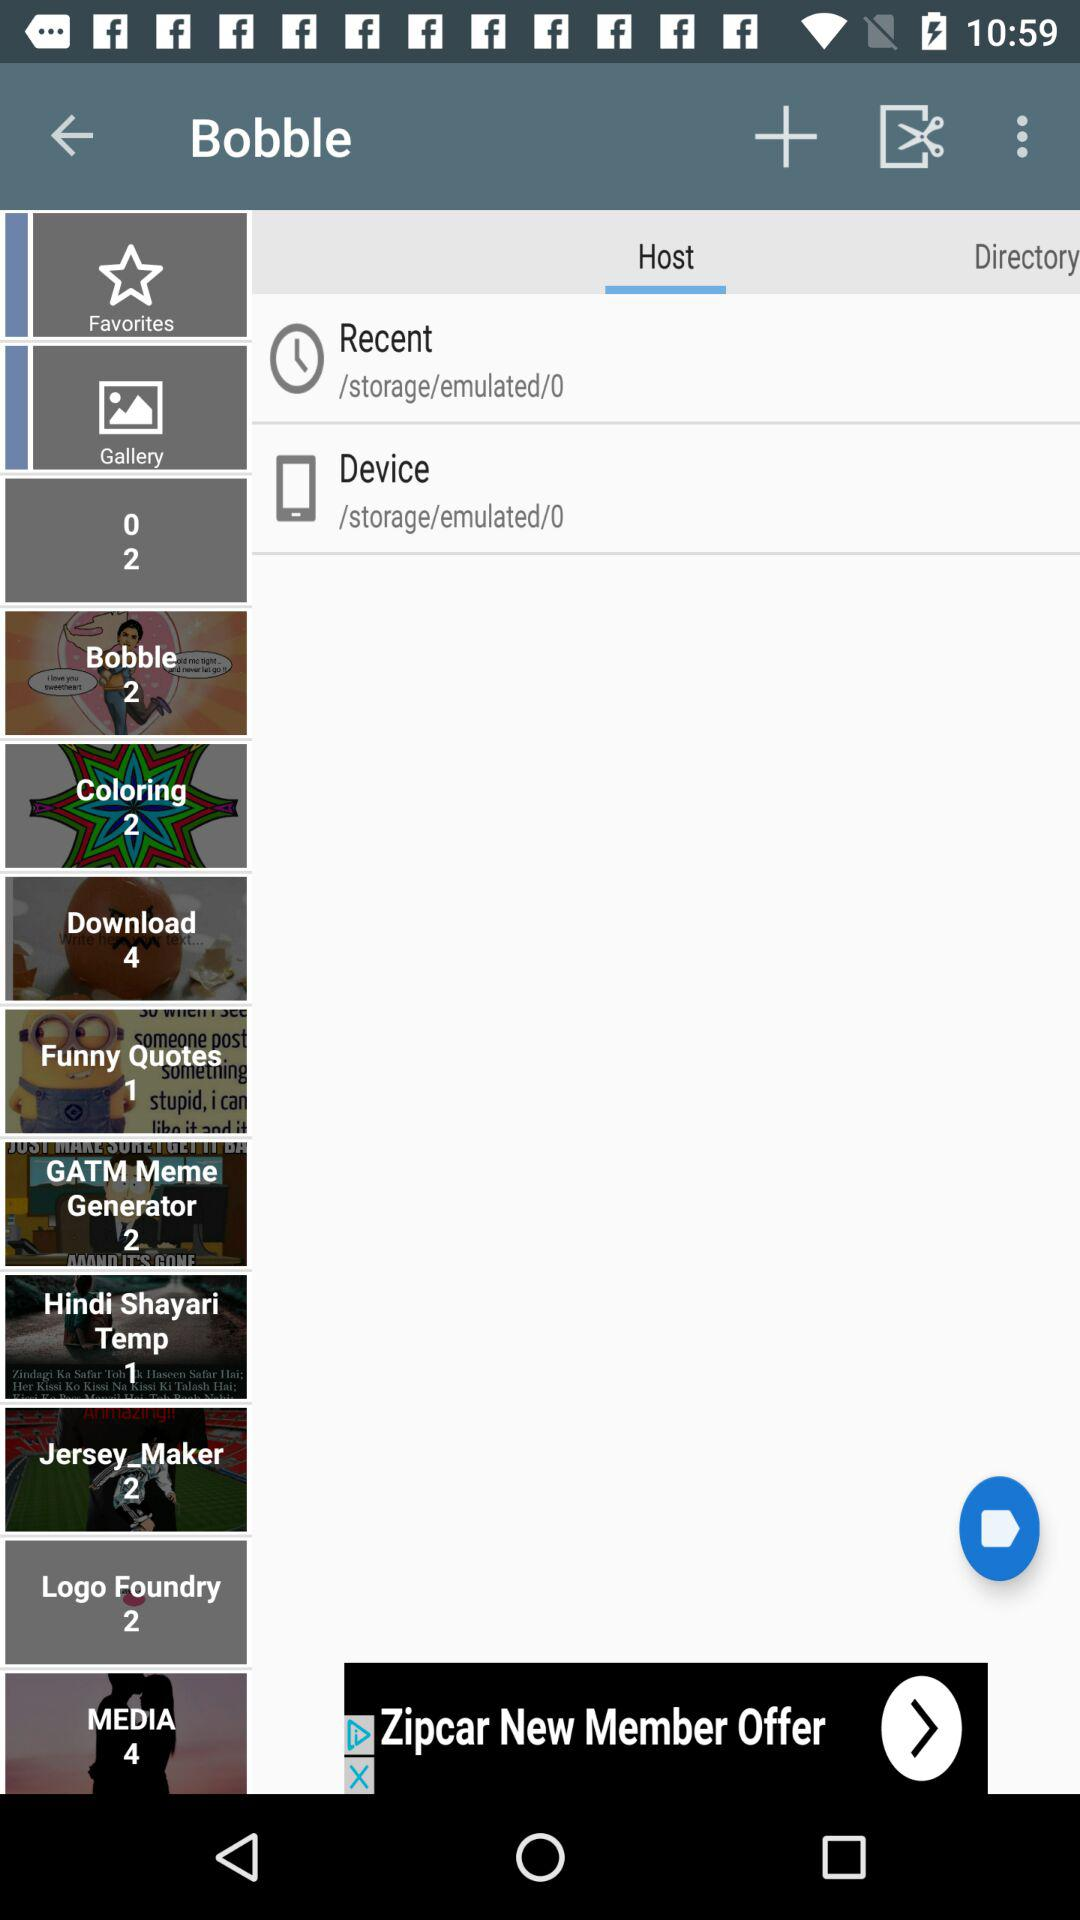What is the name of the application? The name of the application is "Bobble". 